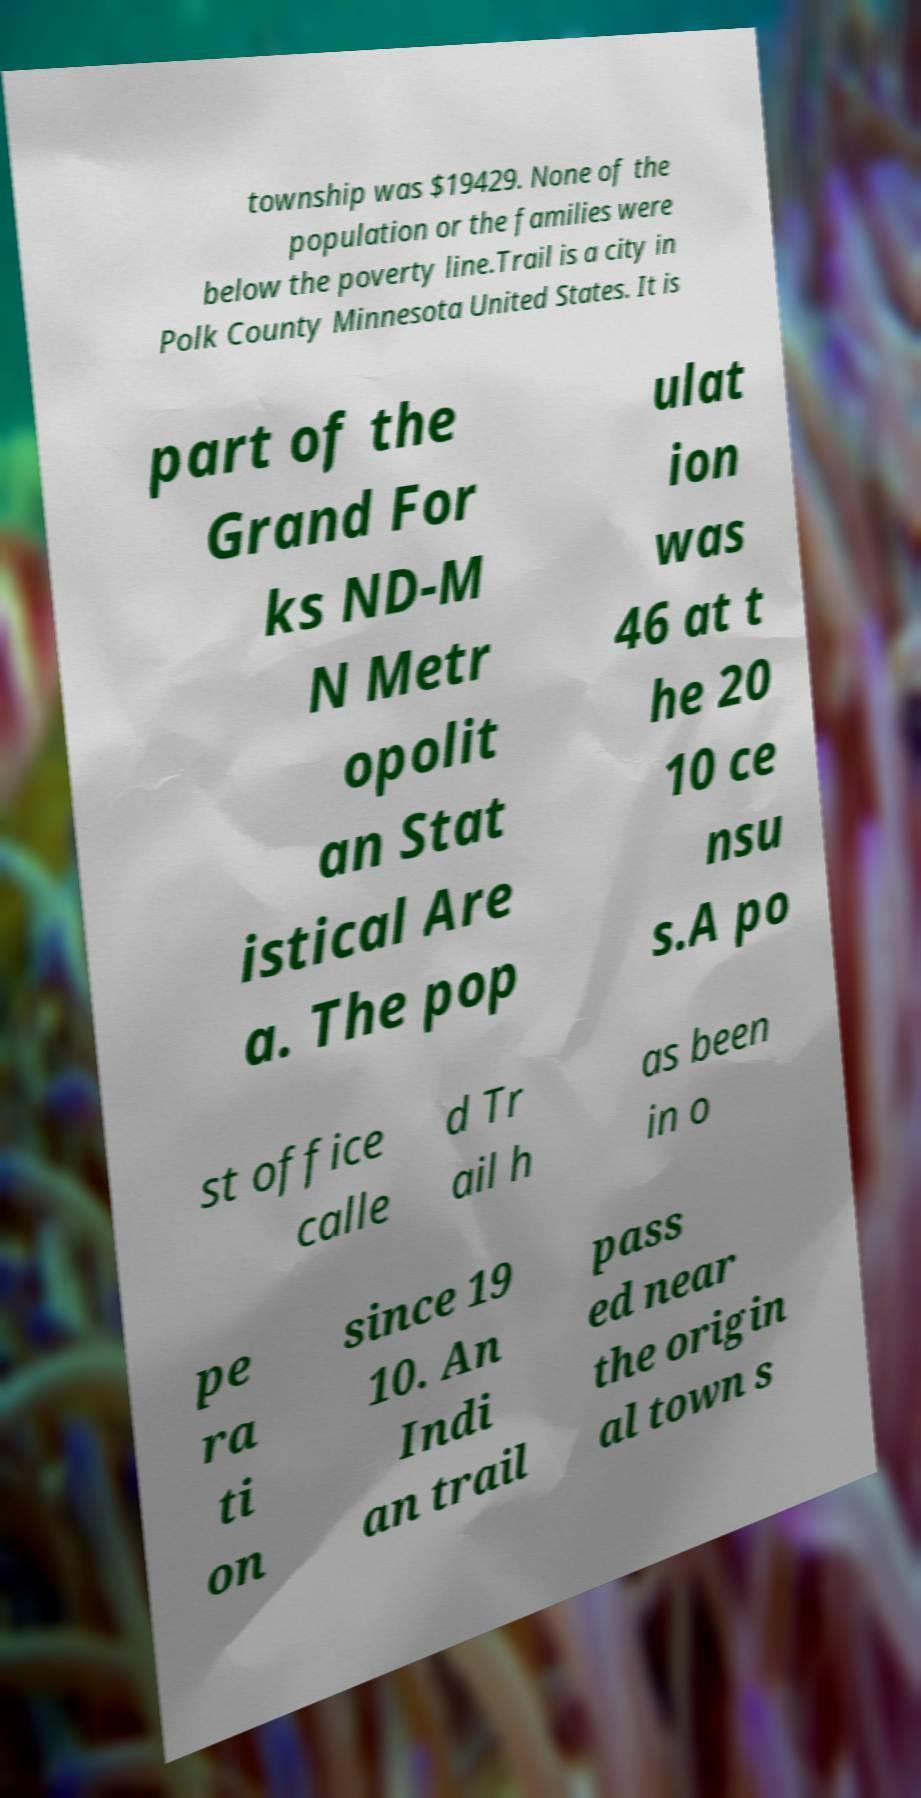I need the written content from this picture converted into text. Can you do that? township was $19429. None of the population or the families were below the poverty line.Trail is a city in Polk County Minnesota United States. It is part of the Grand For ks ND-M N Metr opolit an Stat istical Are a. The pop ulat ion was 46 at t he 20 10 ce nsu s.A po st office calle d Tr ail h as been in o pe ra ti on since 19 10. An Indi an trail pass ed near the origin al town s 